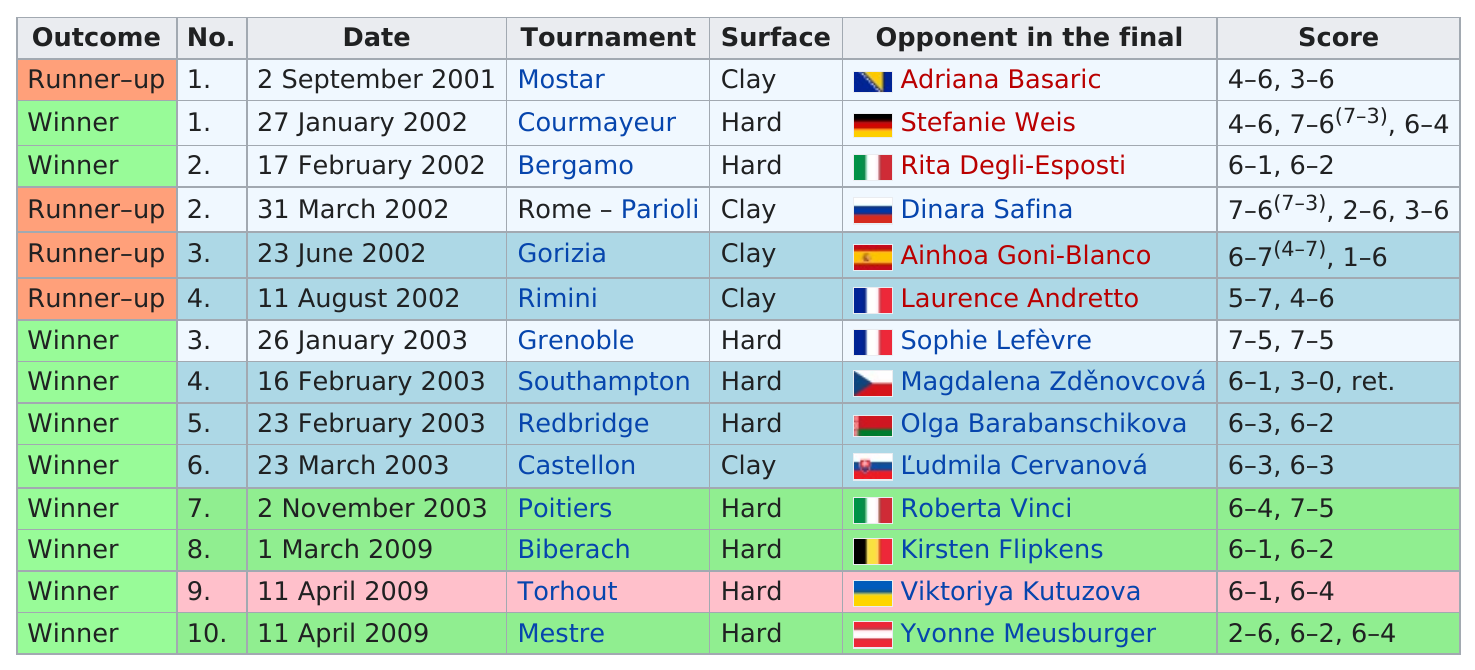Indicate a few pertinent items in this graphic. Karolina Šprem was the runner-up in the Mostar tournament in 2001, which was the only tournament where she reached this position. She won and played on a clay surface a total of 1 time. The surface was clay 5 times. In 2002, she played a total of 5 games. Yvonne Meusburger was the opponent of the person in the April 2009 Mestre tournament. 